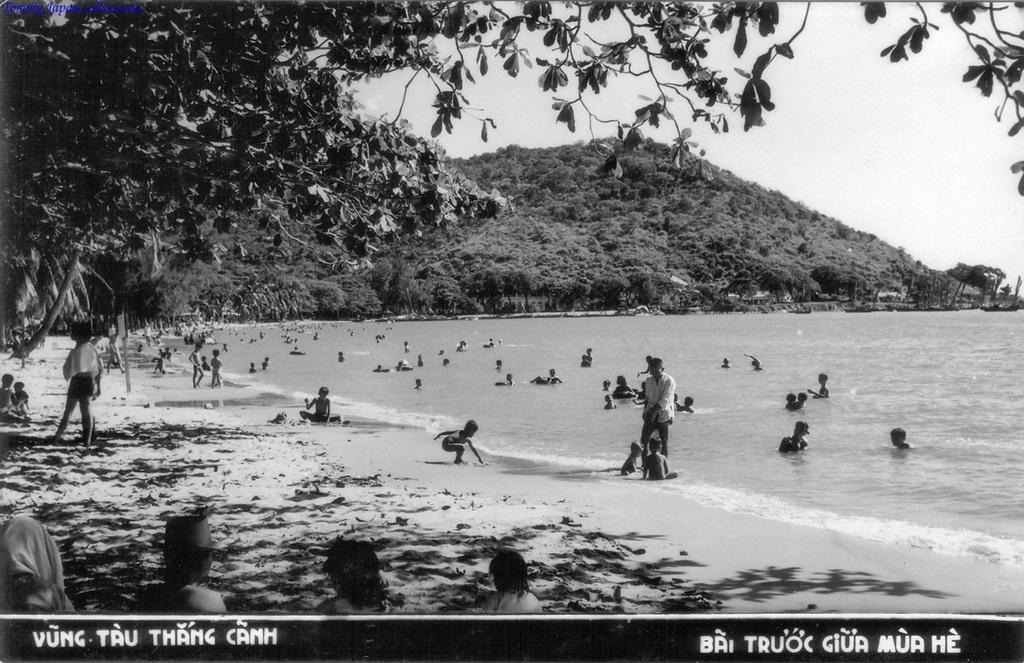What can be seen on the left side of the image? There is a watermark on the left side of the image. What can be seen on the right side of the image? There is a watermark on the right side of the image. What is happening in the background of the image? There are persons in the water and trees in the background of the image. What other geographical features can be seen in the background of the image? There is a mountain in the background of the image. What is visible in the sky in the background of the image? The sky is visible in the background of the image. What direction are the trees growing in the image? The direction in which the trees are growing cannot be determined from the image, as trees typically grow upward and not in a specific direction. 